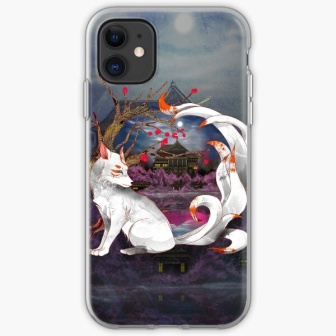Describe the main elements and their placement in this image. The image features a central white fox, radiating grace and elegance, positioned on a purple rock. Its bushy tail curls around it, which is adorned by a white ribbon. The scene is set against a dark blue sky, highlighted by a bright full moon. Towards the background, an enigmatic castle is partially visible. Throughout the design, striking red flowers and branches add vibrant accents. What can you infer about the atmosphere and mood of this scene? The atmosphere of the scene is one of mystique and elegance, with an underlying sense of tranquility. The moonlit night suggests a calm and serene setting, while elements like the castle introduce an air of mystery. The intricate design of the fox, along with the vibrant yet balanced color palette of white, purple, and red, collectively evoke a feeling of magical realism. Imagine a story that could be set in the world depicted by this image. In a distant, mystical land where the moonlight holds ancient wisdom and nature thrives in vibrant harmony, the white fox is a revered guardian of the enchanted forest. The fox's ribbon is an artifact of immense power, bestowed upon it by the spirits of the moon. One night, under the full moon's glow, the fox embarks on a quest to uncover the secrets of the ancient castle that emerges only in the lunar light. Traversing through fields of crimson flowers, whispering tales of forgotten times, the fox must journey through challenges and unveil mysteries that bind the lands in secrecy and wonder.  What does the contrast between the colors in this design tell you about its artistic choices? The contrast between the colors in this design highlights the artist’s deliberate choice to create visual interest and emphasize specific elements. The stark white of the fox stands out as the focal point against the darker background, symbolizing purity and prominence. The rich purples and deep blues add a layer of depth and mysticism, while the red flowers serve as vibrant accents that draw the eye and signify life and passion. This combination of colors not only makes the design aesthetically pleasing but also imbues it with emotional and symbolic depth, guiding the viewer's interpretation and experience of the scene. 